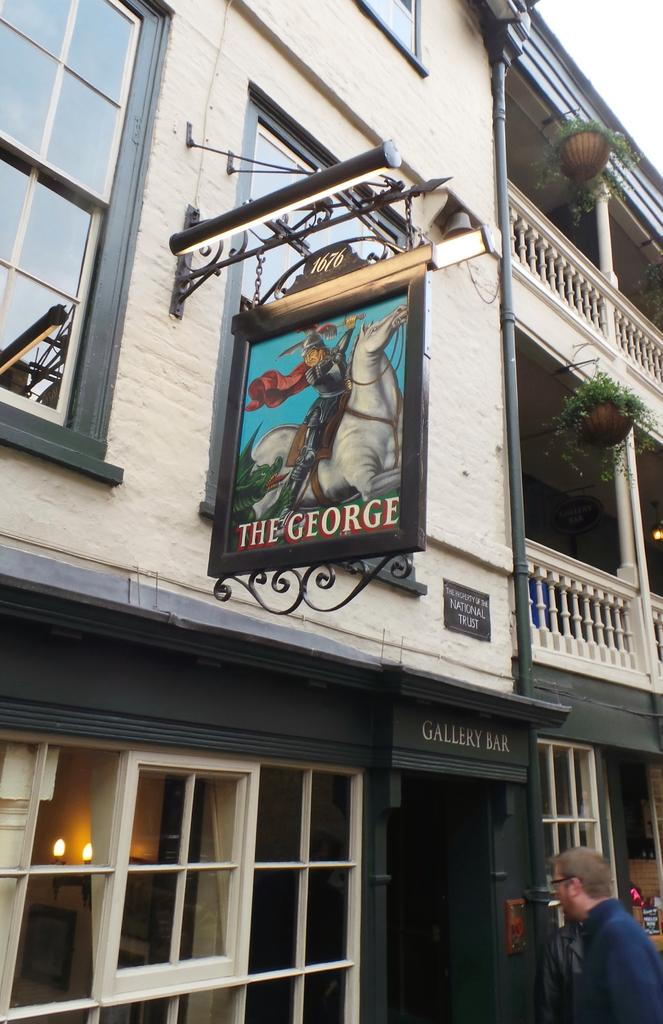What type of structure is present in the image? There is a building in the image. What is attached to the building? There is a hoarding in the image. What can be seen growing in the image? There are plants in the image. Who or what is present in the image? There is a person in the image. What type of material is used for the windows in the building? There are glass windows in the image. What type of copper channel can be seen in the image? There is no copper channel present in the image. Is there a rifle visible in the image? There is no rifle present in the image. 